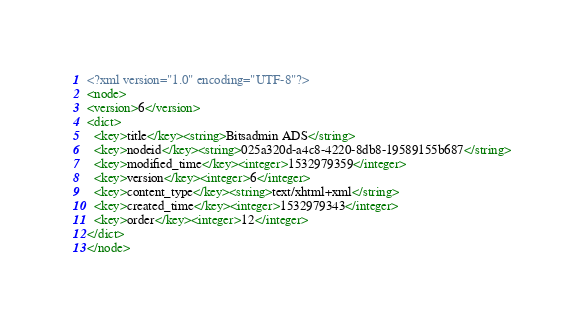<code> <loc_0><loc_0><loc_500><loc_500><_XML_><?xml version="1.0" encoding="UTF-8"?>
<node>
<version>6</version>
<dict>
  <key>title</key><string>Bitsadmin ADS</string>
  <key>nodeid</key><string>025a320d-a4c8-4220-8db8-19589155b687</string>
  <key>modified_time</key><integer>1532979359</integer>
  <key>version</key><integer>6</integer>
  <key>content_type</key><string>text/xhtml+xml</string>
  <key>created_time</key><integer>1532979343</integer>
  <key>order</key><integer>12</integer>
</dict>
</node>
</code> 